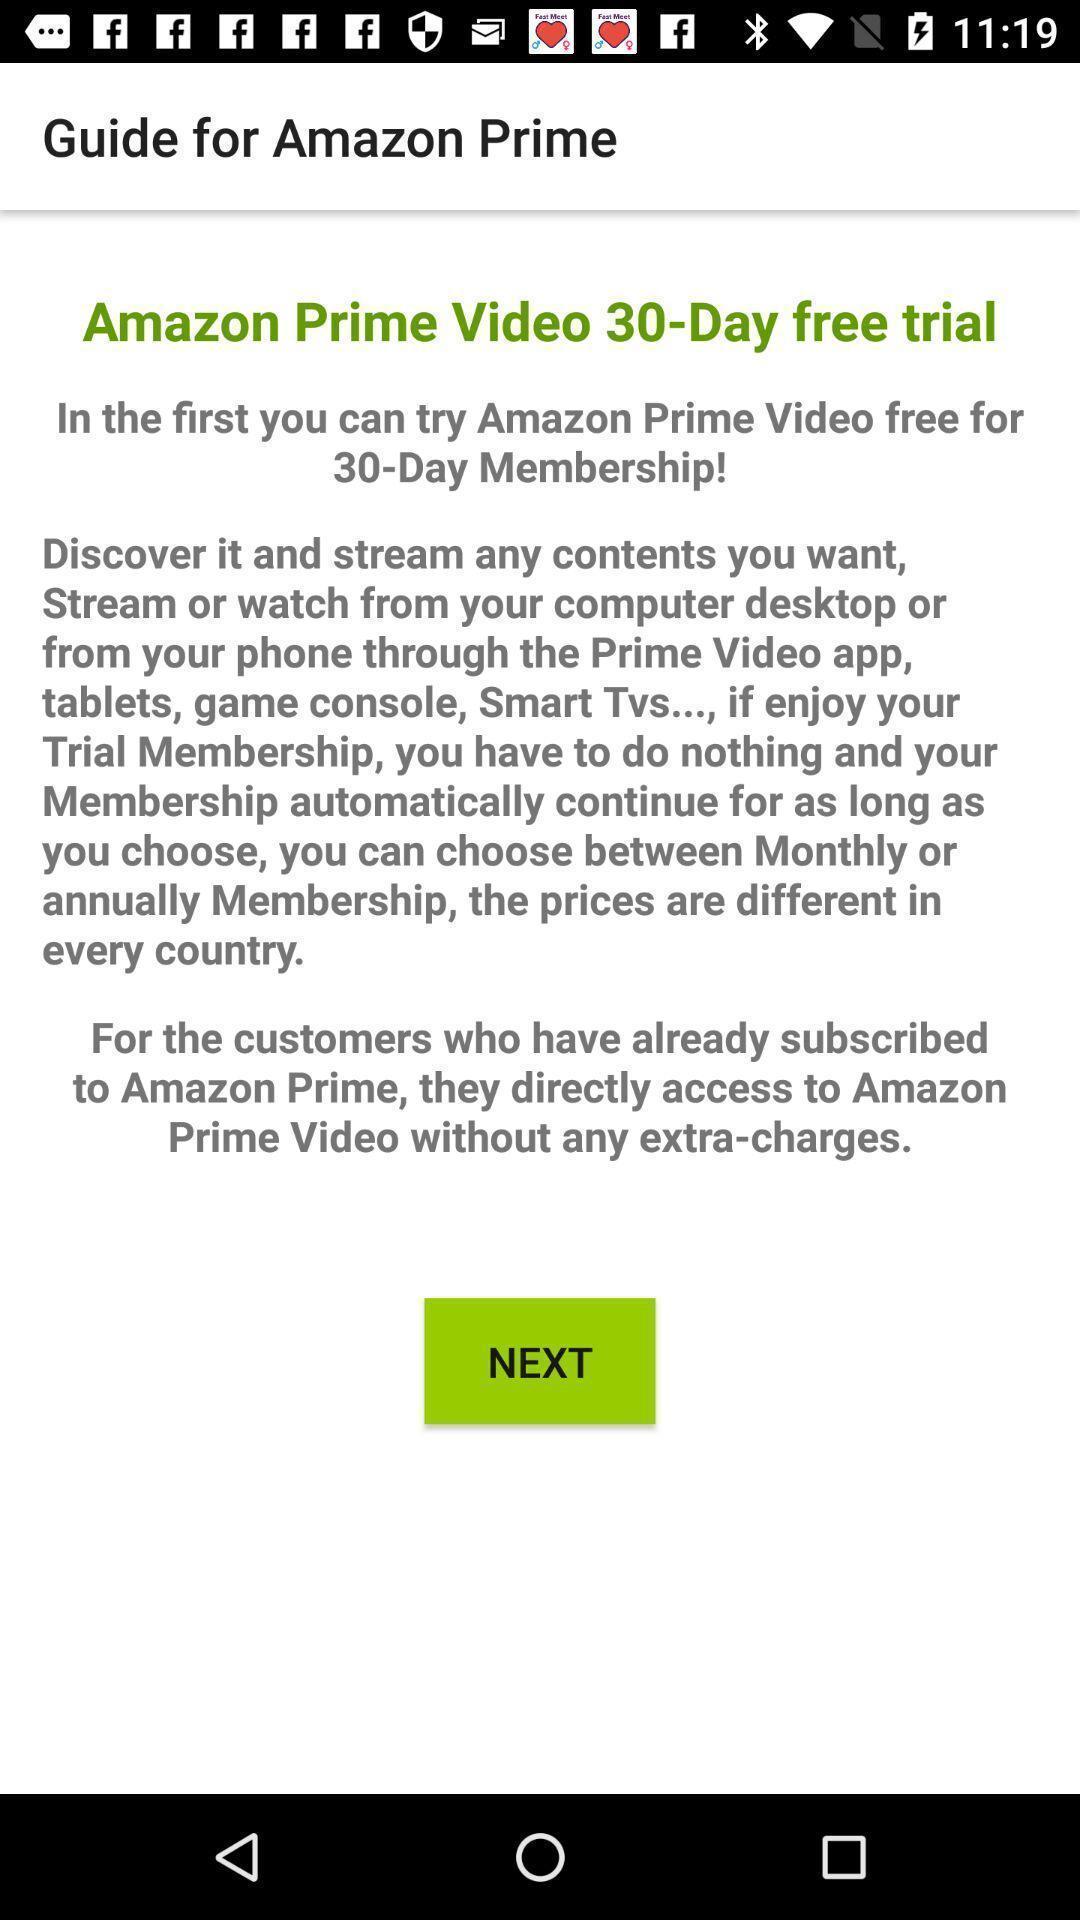Summarize the information in this screenshot. Page displaying membership of a social app. 